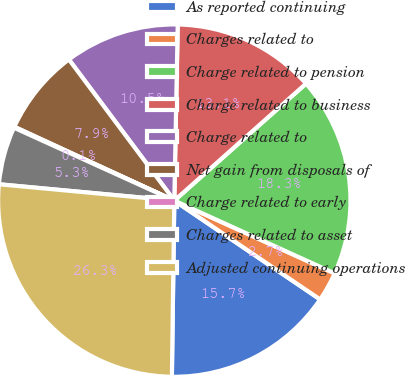<chart> <loc_0><loc_0><loc_500><loc_500><pie_chart><fcel>As reported continuing<fcel>Charges related to<fcel>Charge related to pension<fcel>Charge related to business<fcel>Charge related to<fcel>Net gain from disposals of<fcel>Charge related to early<fcel>Charges related to asset<fcel>Adjusted continuing operations<nl><fcel>15.74%<fcel>2.7%<fcel>18.34%<fcel>13.13%<fcel>10.52%<fcel>7.91%<fcel>0.09%<fcel>5.31%<fcel>26.26%<nl></chart> 